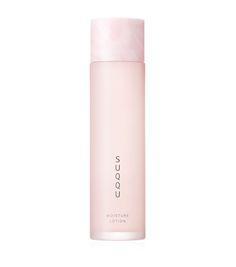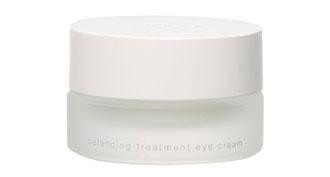The first image is the image on the left, the second image is the image on the right. Given the left and right images, does the statement "One image shows an upright cylindrical bottle and the other shows a short pot-shaped product." hold true? Answer yes or no. Yes. The first image is the image on the left, the second image is the image on the right. Considering the images on both sides, is "Each container has a round shape." valid? Answer yes or no. Yes. 